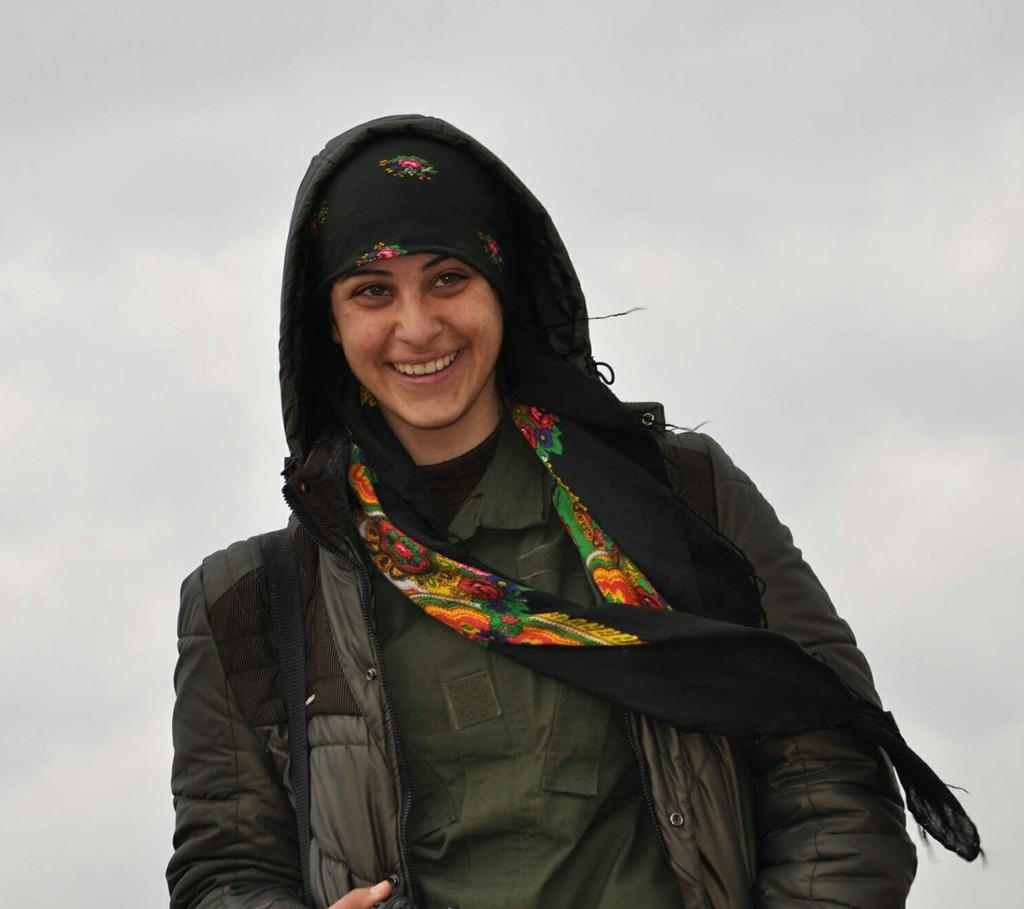Who is present in the image? There is a woman in the image. What is the woman wearing on her upper body? The woman is wearing a green jacket. What accessory is the woman wearing around her neck? The woman is wearing a black scarf. What can be seen in the distance in the image? There is a sky visible in the background of the image. What type of ball is being used by the woman in the image? There is no ball present in the image; the woman is not holding or using any ball. 